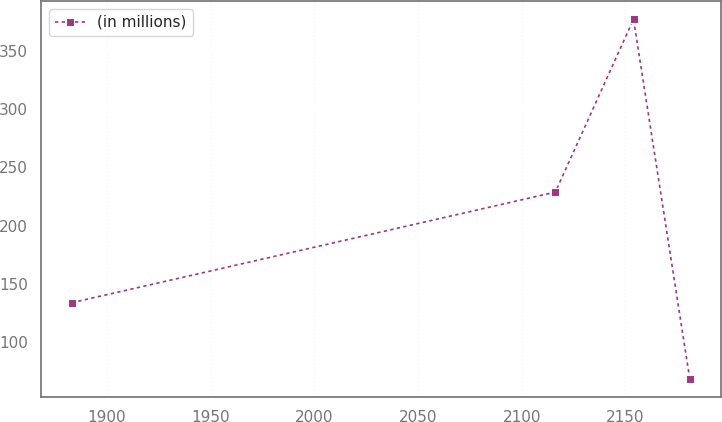Convert chart. <chart><loc_0><loc_0><loc_500><loc_500><line_chart><ecel><fcel>(in millions)<nl><fcel>1882.98<fcel>133.67<nl><fcel>2116.22<fcel>228.74<nl><fcel>2153.94<fcel>377.4<nl><fcel>2181.04<fcel>68.41<nl></chart> 